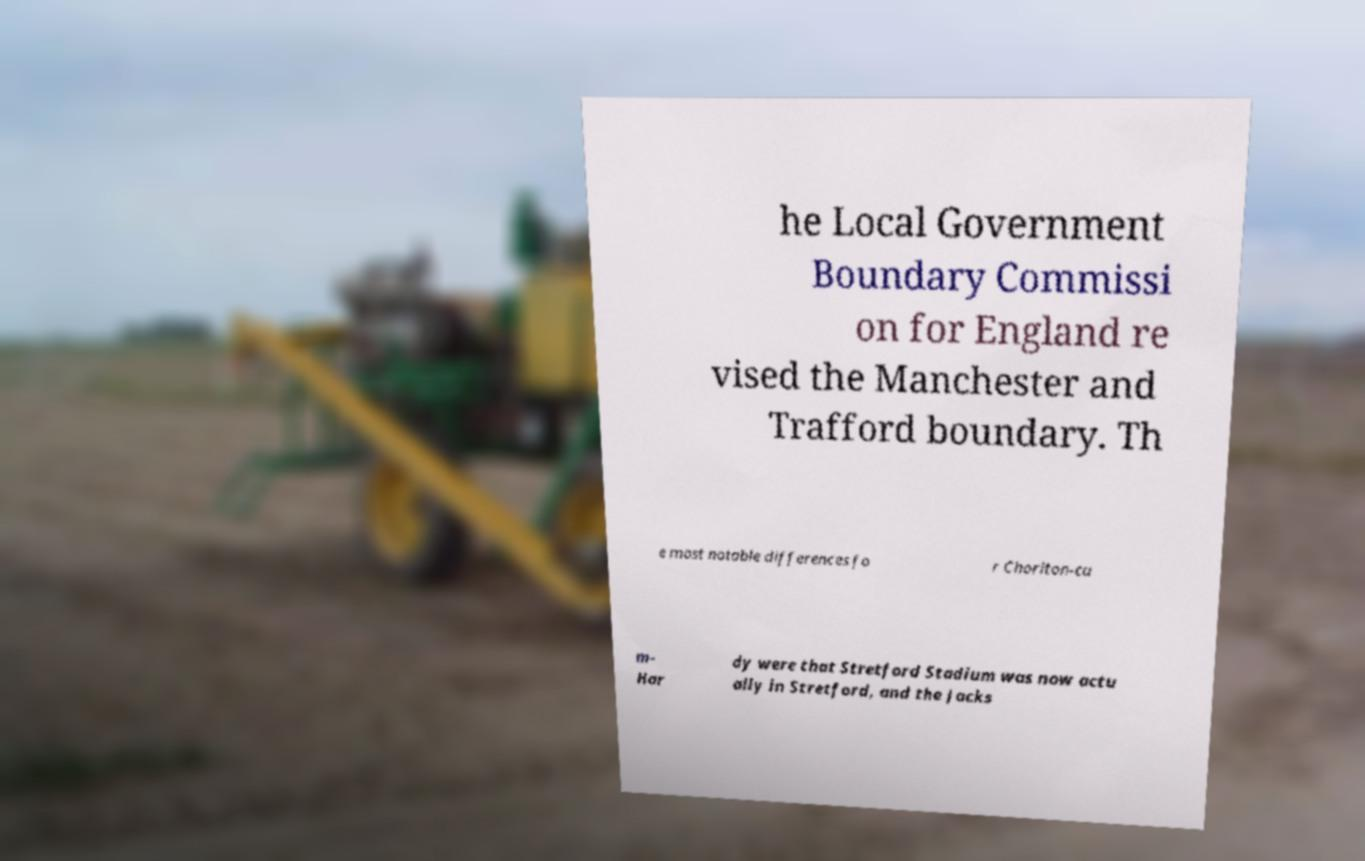Please identify and transcribe the text found in this image. he Local Government Boundary Commissi on for England re vised the Manchester and Trafford boundary. Th e most notable differences fo r Chorlton-cu m- Har dy were that Stretford Stadium was now actu ally in Stretford, and the Jacks 